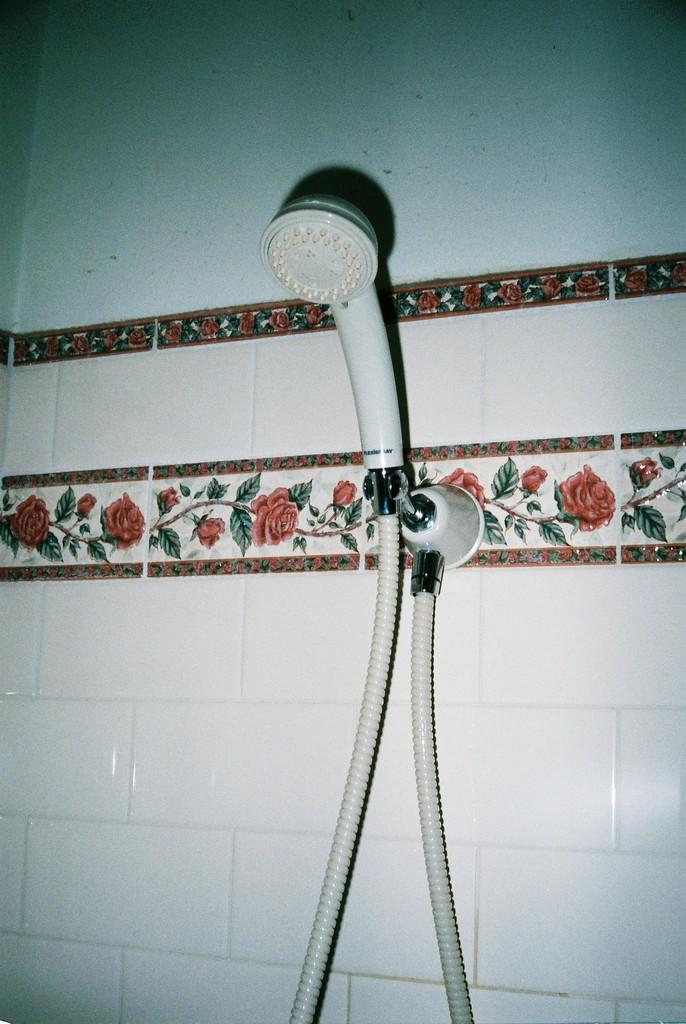What is the main object in the image? There is a hand shower with a pipe in the image. How is the hand shower connected to the wall? The hand shower is attached to the wall. What can be seen on the wall in the image? There are tiles with a design in the image. What type of eggnog is being served in the image? There is no eggnog present in the image; it features a hand shower with a pipe and tiles with a design. What key is used to unlock the hand shower in the image? There is no key involved in using the hand shower in the image; it is attached to the wall and does not require a key for operation. 